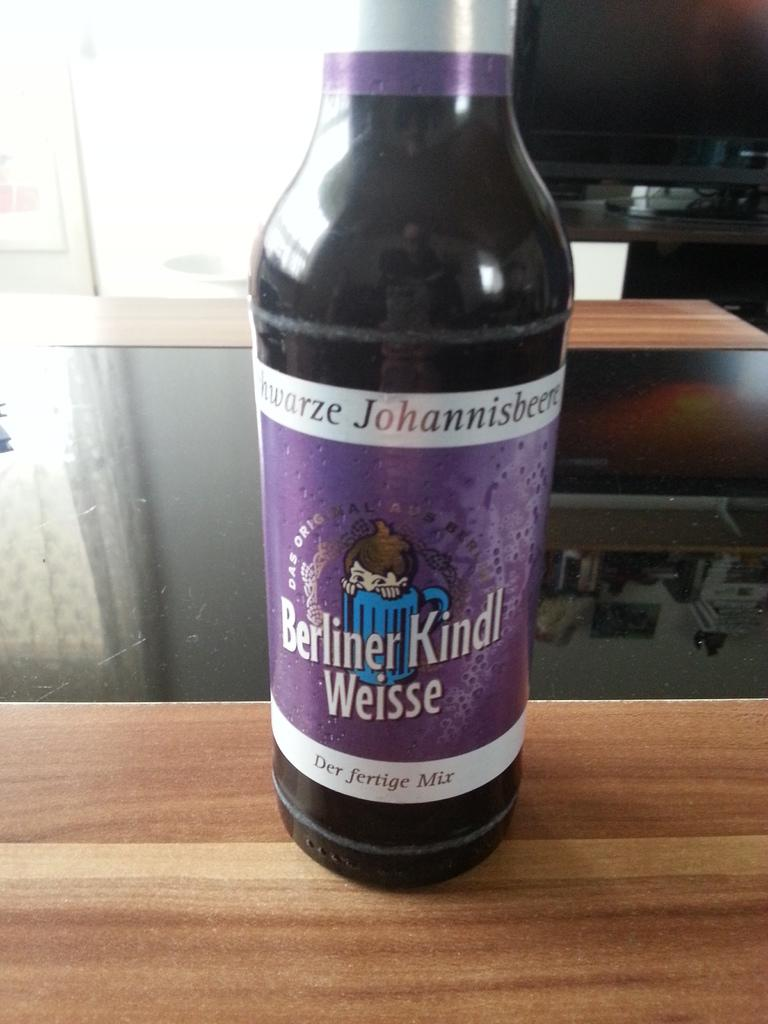<image>
Offer a succinct explanation of the picture presented. A beverage bottle with a purple label that says Berliner Kindl Weisse is on a woden surface, across from a window in a house. 